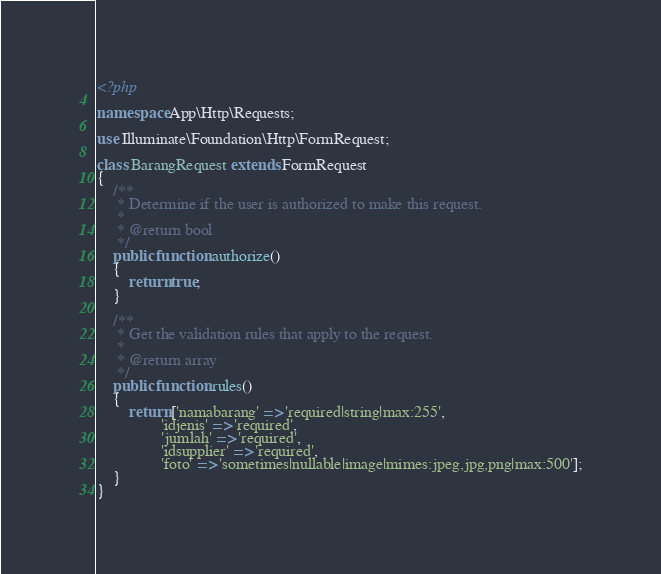<code> <loc_0><loc_0><loc_500><loc_500><_PHP_><?php

namespace App\Http\Requests;

use Illuminate\Foundation\Http\FormRequest;

class BarangRequest extends FormRequest
{
    /**
     * Determine if the user is authorized to make this request.
     *
     * @return bool
     */
    public function authorize()
    {
        return true;
    }

    /**
     * Get the validation rules that apply to the request.
     *
     * @return array
     */
    public function rules()
    {
        return ['namabarang' => 'required|string|max:255',
                'idjenis' => 'required',
                'jumlah' => 'required',
                'idsupplier' => 'required',
                'foto' => 'sometimes|nullable|image|mimes:jpeg,jpg,png|max:500'];
    }
}

</code> 